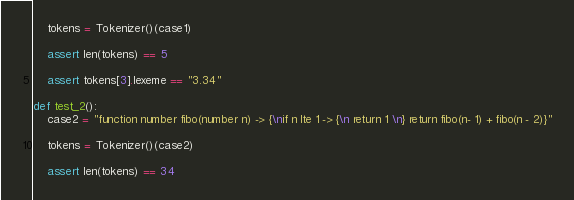<code> <loc_0><loc_0><loc_500><loc_500><_Python_>    tokens = Tokenizer()(case1)

    assert len(tokens) == 5

    assert tokens[3].lexeme == "3.34"

def test_2():
    case2 = "function number fibo(number n) -> {\nif n lte 1 -> {\n return 1 \n} return fibo(n- 1) + fibo(n - 2)}"
    
    tokens = Tokenizer()(case2)
    
    assert len(tokens) == 34

</code> 